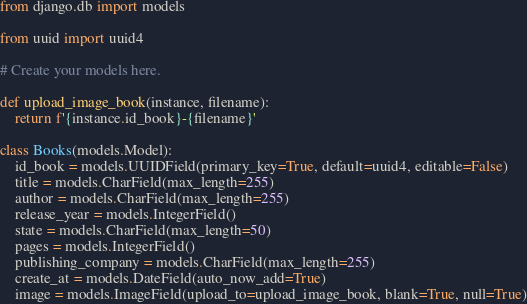<code> <loc_0><loc_0><loc_500><loc_500><_Python_>from django.db import models

from uuid import uuid4

# Create your models here.

def upload_image_book(instance, filename):
    return f'{instance.id_book}-{filename}'

class Books(models.Model):
    id_book = models.UUIDField(primary_key=True, default=uuid4, editable=False)
    title = models.CharField(max_length=255)
    author = models.CharField(max_length=255)
    release_year = models.IntegerField()
    state = models.CharField(max_length=50)
    pages = models.IntegerField()
    publishing_company = models.CharField(max_length=255)
    create_at = models.DateField(auto_now_add=True)
    image = models.ImageField(upload_to=upload_image_book, blank=True, null=True)</code> 